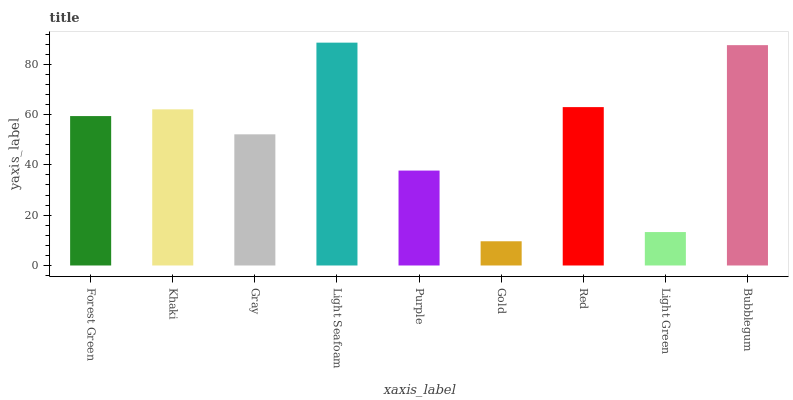Is Gold the minimum?
Answer yes or no. Yes. Is Light Seafoam the maximum?
Answer yes or no. Yes. Is Khaki the minimum?
Answer yes or no. No. Is Khaki the maximum?
Answer yes or no. No. Is Khaki greater than Forest Green?
Answer yes or no. Yes. Is Forest Green less than Khaki?
Answer yes or no. Yes. Is Forest Green greater than Khaki?
Answer yes or no. No. Is Khaki less than Forest Green?
Answer yes or no. No. Is Forest Green the high median?
Answer yes or no. Yes. Is Forest Green the low median?
Answer yes or no. Yes. Is Khaki the high median?
Answer yes or no. No. Is Khaki the low median?
Answer yes or no. No. 